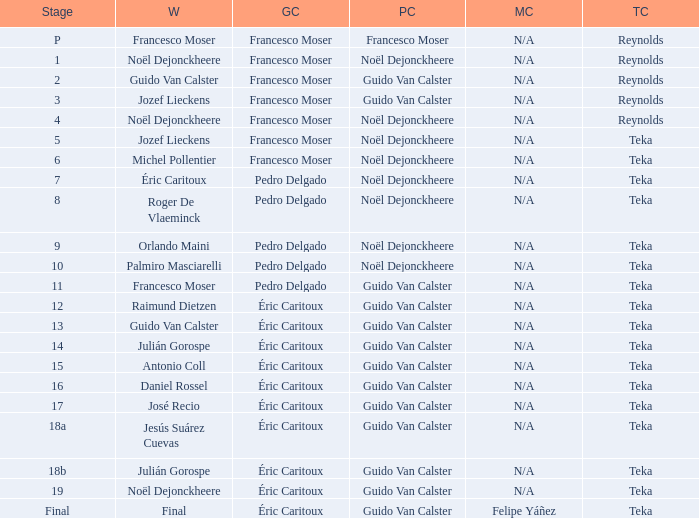Name the points classification of stage 16 Guido Van Calster. 